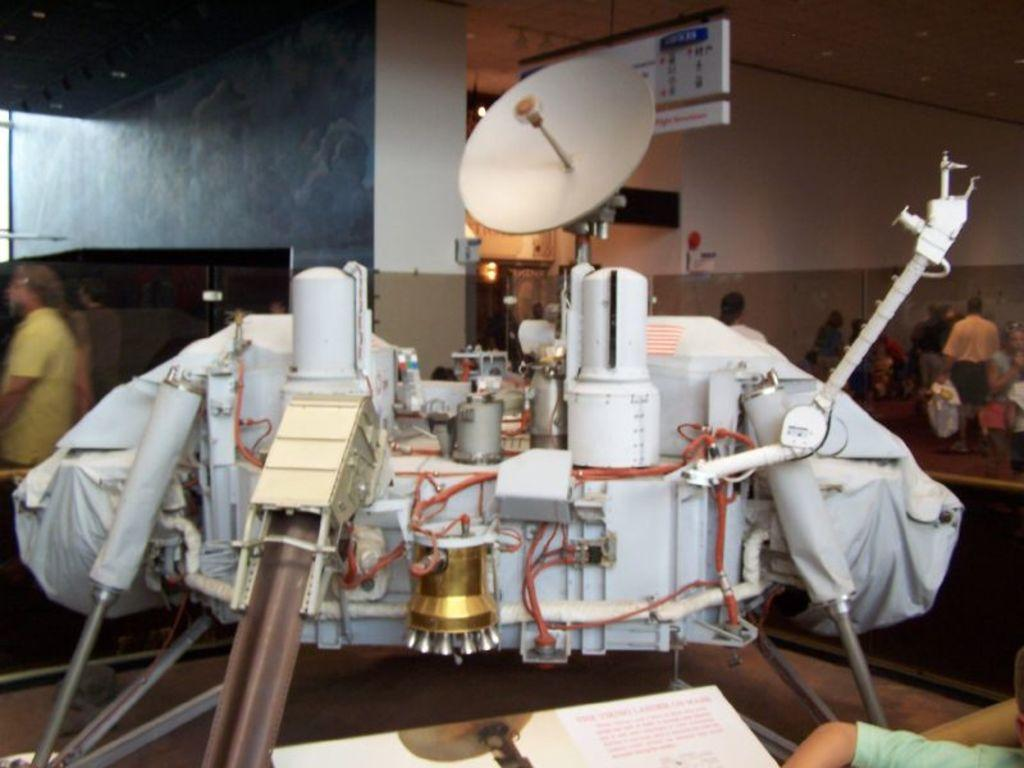What is located on the table in the image? There is an object on the table in the image. What can be seen in the background of the image? There are people and a wall in the background of the image. What is hanging on the wall in the background of the image? There is a banner hanging on the wall in the background of the image. Is there any blood visible on the banner in the image? No, there is no blood visible on the banner in the image. 